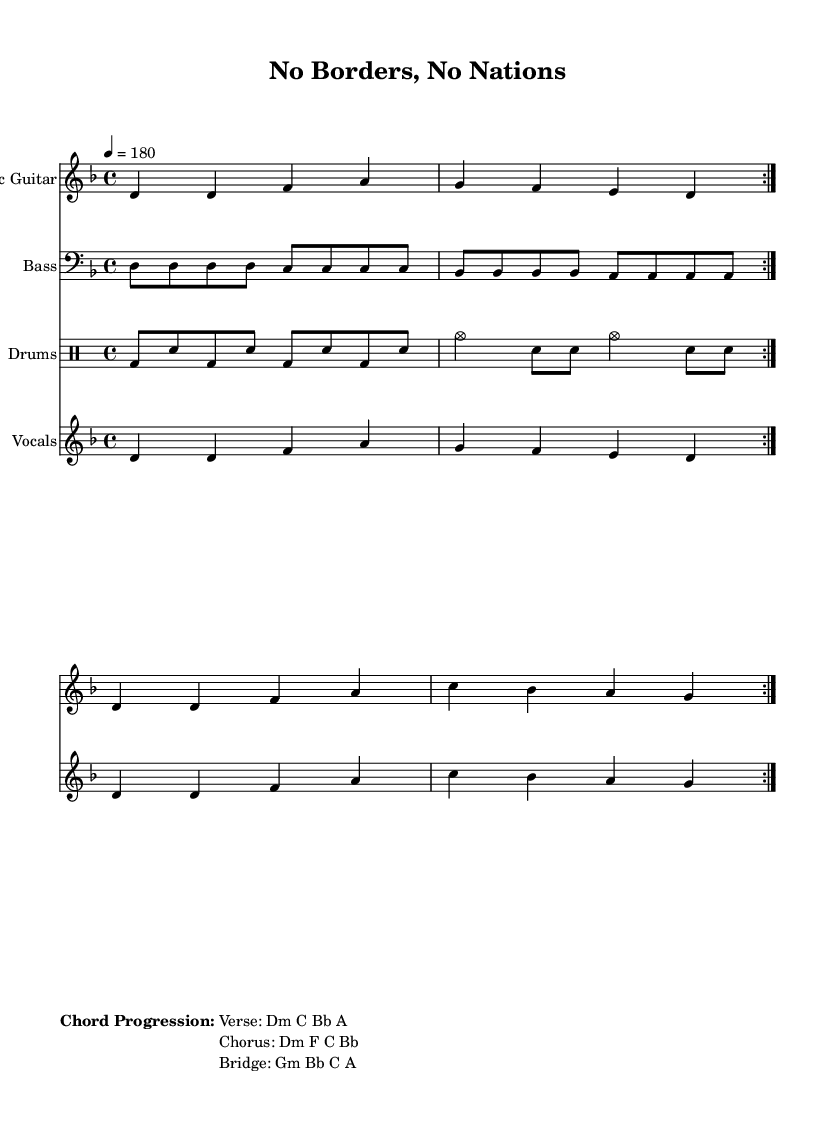What is the key signature of this music? The key signature is indicated at the beginning of the music. It shows one flat, which corresponds to the key of D minor.
Answer: D minor What is the time signature of this music? The time signature is shown as 4/4, meaning there are four beats in each measure and the quarter note gets one beat.
Answer: 4/4 What is the tempo marking of this piece? The tempo marking is given at the start, indicating the speed of the music. It is marked as a quarter note equals 180 beats per minute.
Answer: 180 How many repeats are indicated in the music? The repeat symbols are present in the score, with one set of repeat markings around the sections for a total of two repetitions.
Answer: Two What is the chord progression for the verse? The chord progression is typically listed below the music, where it shows the sequence of chords used in the verse, which is D minor, C, B flat, and A.
Answer: Dm C Bb A How does the chorus differ from the verse in terms of chords? The chorus is different by having a new chord progression listed, showing D minor, F, C, and B flat, distinguishing it from the verse which uses four different chords.
Answer: Dm F C Bb What lyrical theme is present in the song's words? The lyrics indicate a theme related to division and liberation, as they mention artificial lines drawn on maps, suggesting a critique of national borders.
Answer: Critique of national borders 